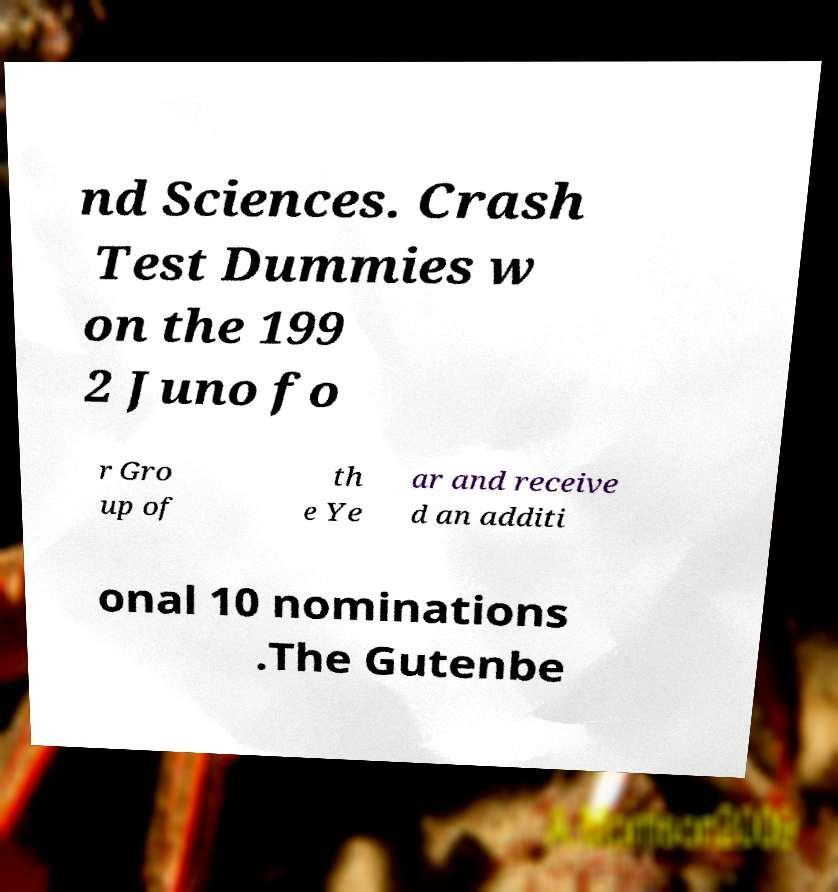Could you assist in decoding the text presented in this image and type it out clearly? nd Sciences. Crash Test Dummies w on the 199 2 Juno fo r Gro up of th e Ye ar and receive d an additi onal 10 nominations .The Gutenbe 